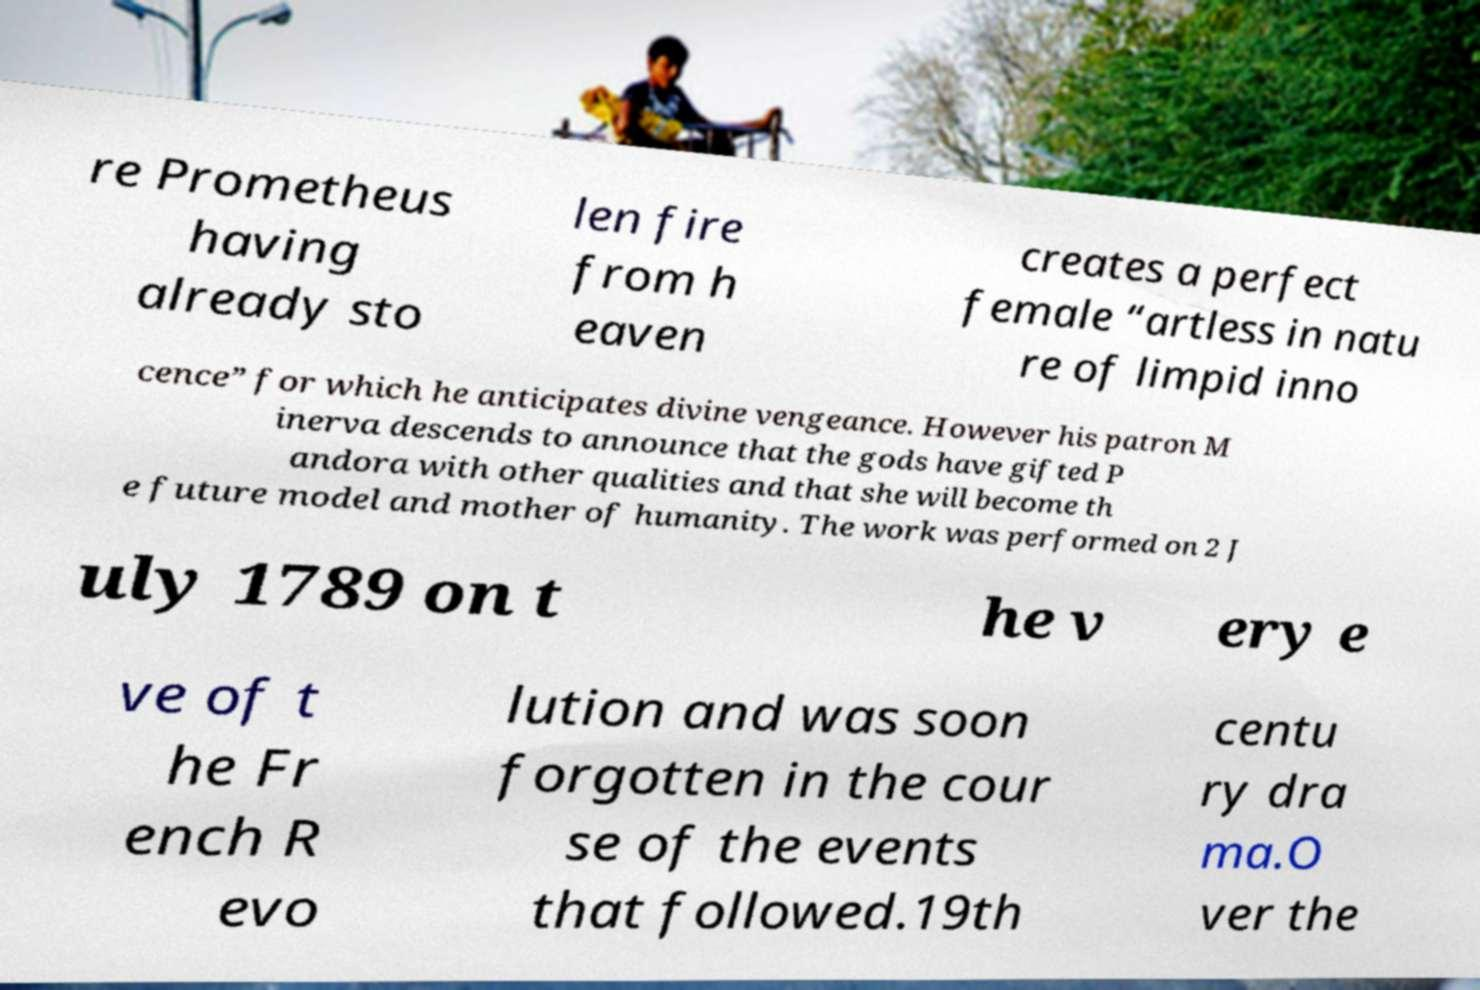Can you read and provide the text displayed in the image?This photo seems to have some interesting text. Can you extract and type it out for me? re Prometheus having already sto len fire from h eaven creates a perfect female “artless in natu re of limpid inno cence” for which he anticipates divine vengeance. However his patron M inerva descends to announce that the gods have gifted P andora with other qualities and that she will become th e future model and mother of humanity. The work was performed on 2 J uly 1789 on t he v ery e ve of t he Fr ench R evo lution and was soon forgotten in the cour se of the events that followed.19th centu ry dra ma.O ver the 